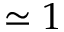<formula> <loc_0><loc_0><loc_500><loc_500>\simeq 1</formula> 